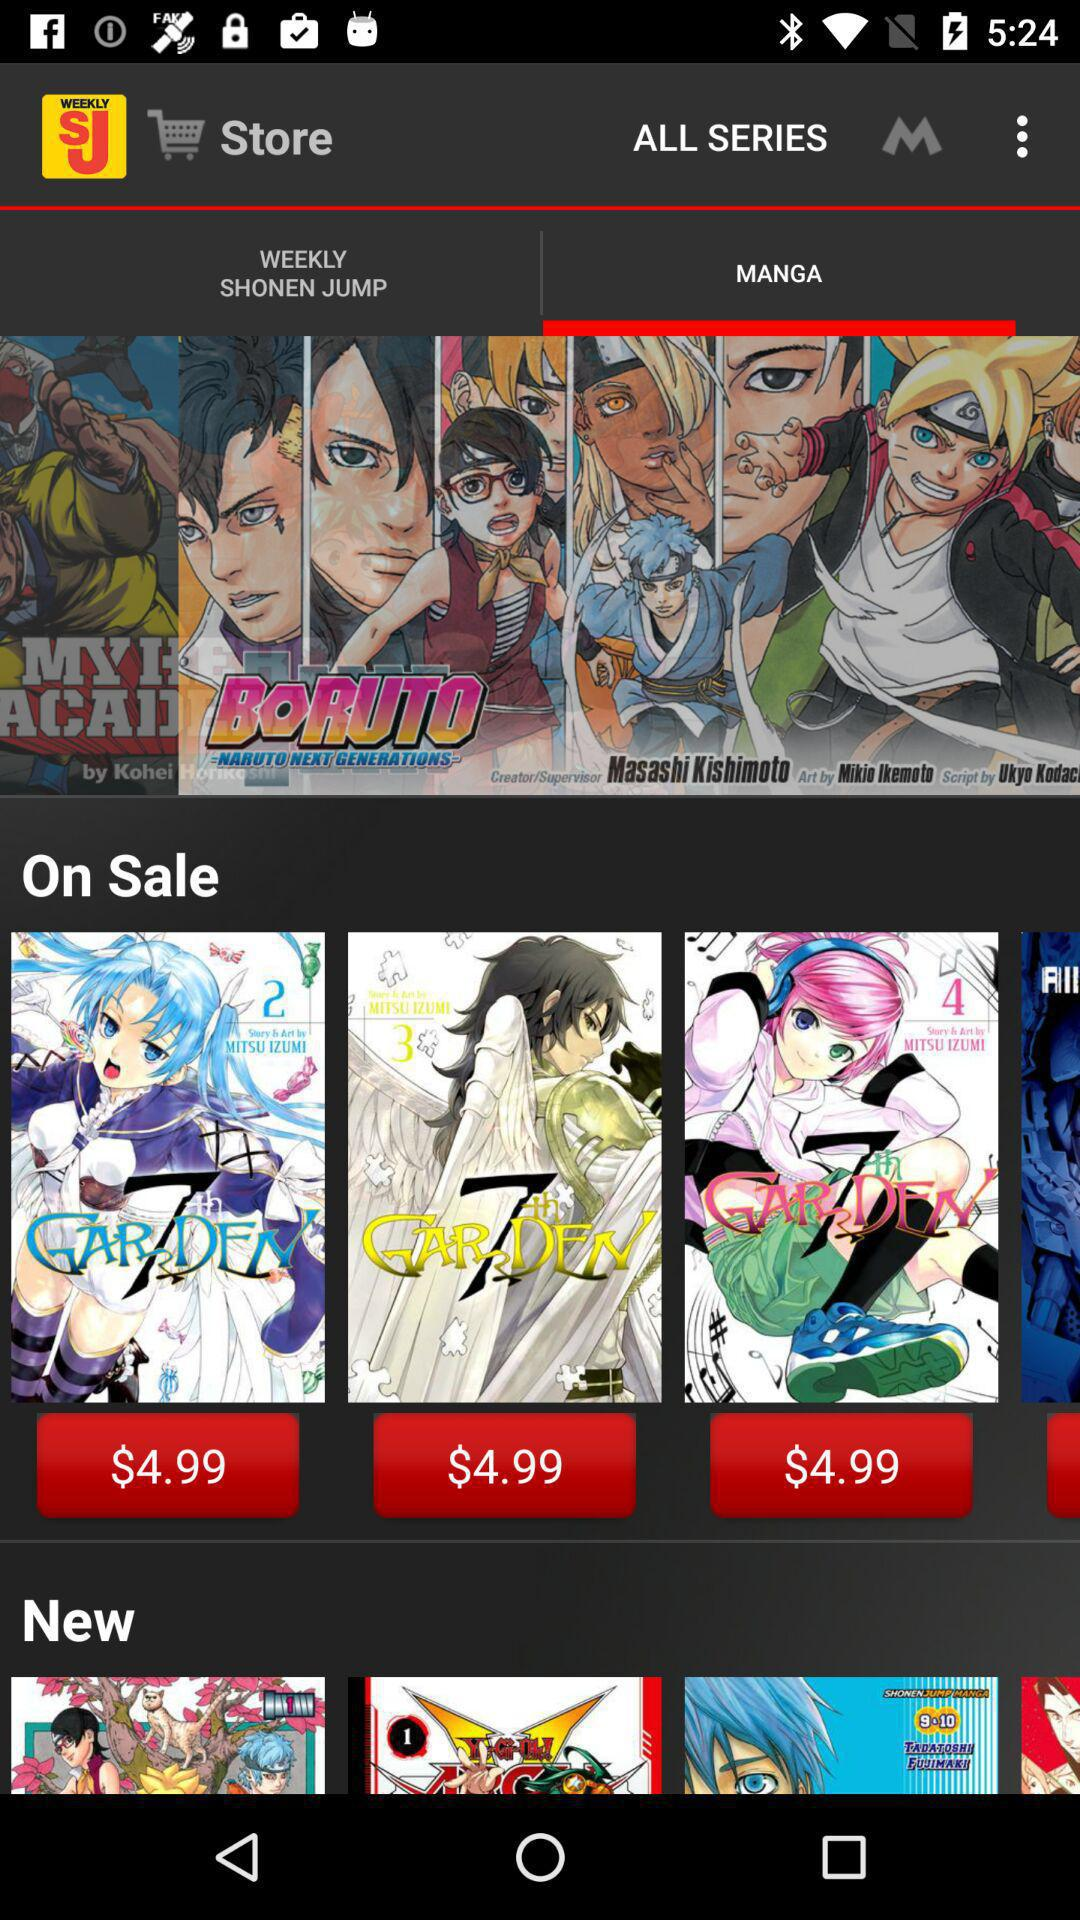How much does a monthly subscription cost? The cost of a monthly subscription is $2.99. 